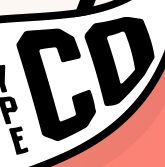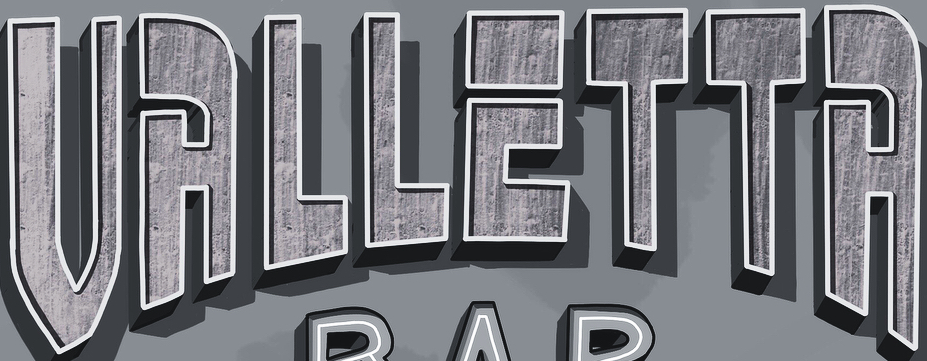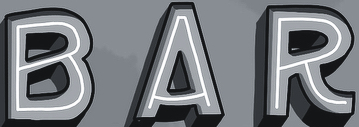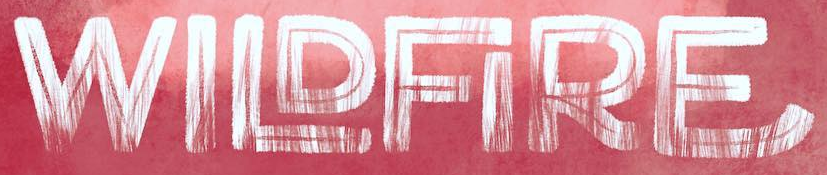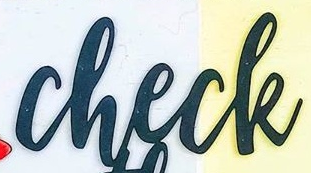What text appears in these images from left to right, separated by a semicolon? CD; VALLETTA; BAR; WILDFIRE; check 